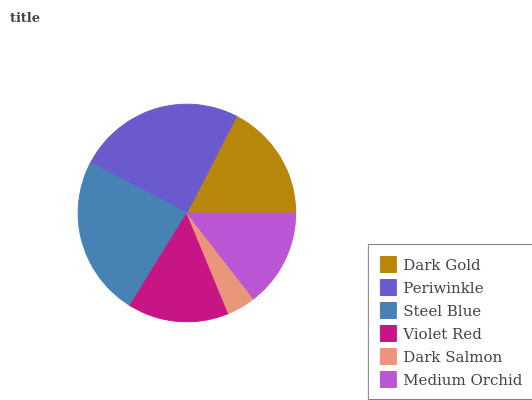Is Dark Salmon the minimum?
Answer yes or no. Yes. Is Periwinkle the maximum?
Answer yes or no. Yes. Is Steel Blue the minimum?
Answer yes or no. No. Is Steel Blue the maximum?
Answer yes or no. No. Is Periwinkle greater than Steel Blue?
Answer yes or no. Yes. Is Steel Blue less than Periwinkle?
Answer yes or no. Yes. Is Steel Blue greater than Periwinkle?
Answer yes or no. No. Is Periwinkle less than Steel Blue?
Answer yes or no. No. Is Dark Gold the high median?
Answer yes or no. Yes. Is Violet Red the low median?
Answer yes or no. Yes. Is Steel Blue the high median?
Answer yes or no. No. Is Dark Salmon the low median?
Answer yes or no. No. 